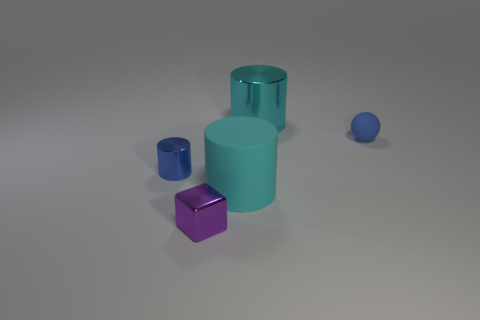How many objects are either large cyan objects or big gray cubes? In the image, there are three large cyan objects and no big gray cubes, making a total of three objects that fit the criteria. 